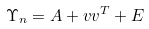Convert formula to latex. <formula><loc_0><loc_0><loc_500><loc_500>\Upsilon _ { n } = A + v v ^ { T } + E</formula> 